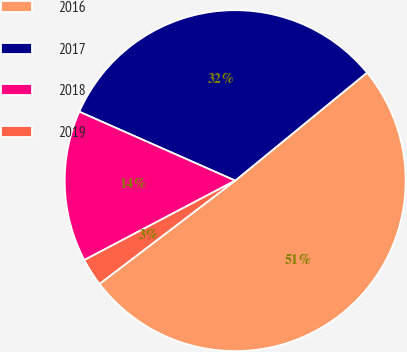Convert chart to OTSL. <chart><loc_0><loc_0><loc_500><loc_500><pie_chart><fcel>2016<fcel>2017<fcel>2018<fcel>2019<nl><fcel>50.57%<fcel>32.45%<fcel>14.34%<fcel>2.64%<nl></chart> 